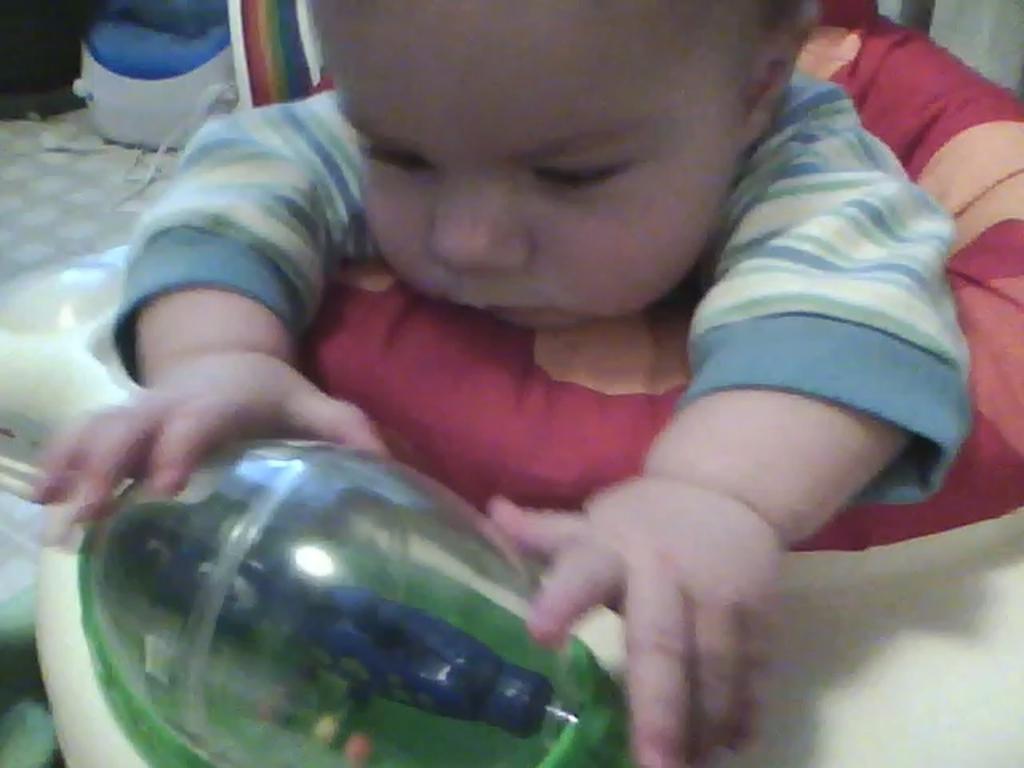How would you summarize this image in a sentence or two? In the image we can see there is a baby sitting in the walker and there is a leg massager kept on the floor. 